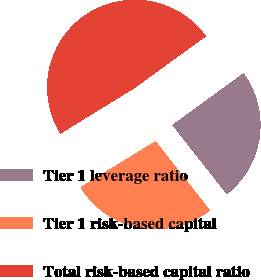Convert chart. <chart><loc_0><loc_0><loc_500><loc_500><pie_chart><fcel>Tier 1 leverage ratio<fcel>Tier 1 risk-based capital<fcel>Total risk-based capital ratio<nl><fcel>24.39%<fcel>26.83%<fcel>48.78%<nl></chart> 